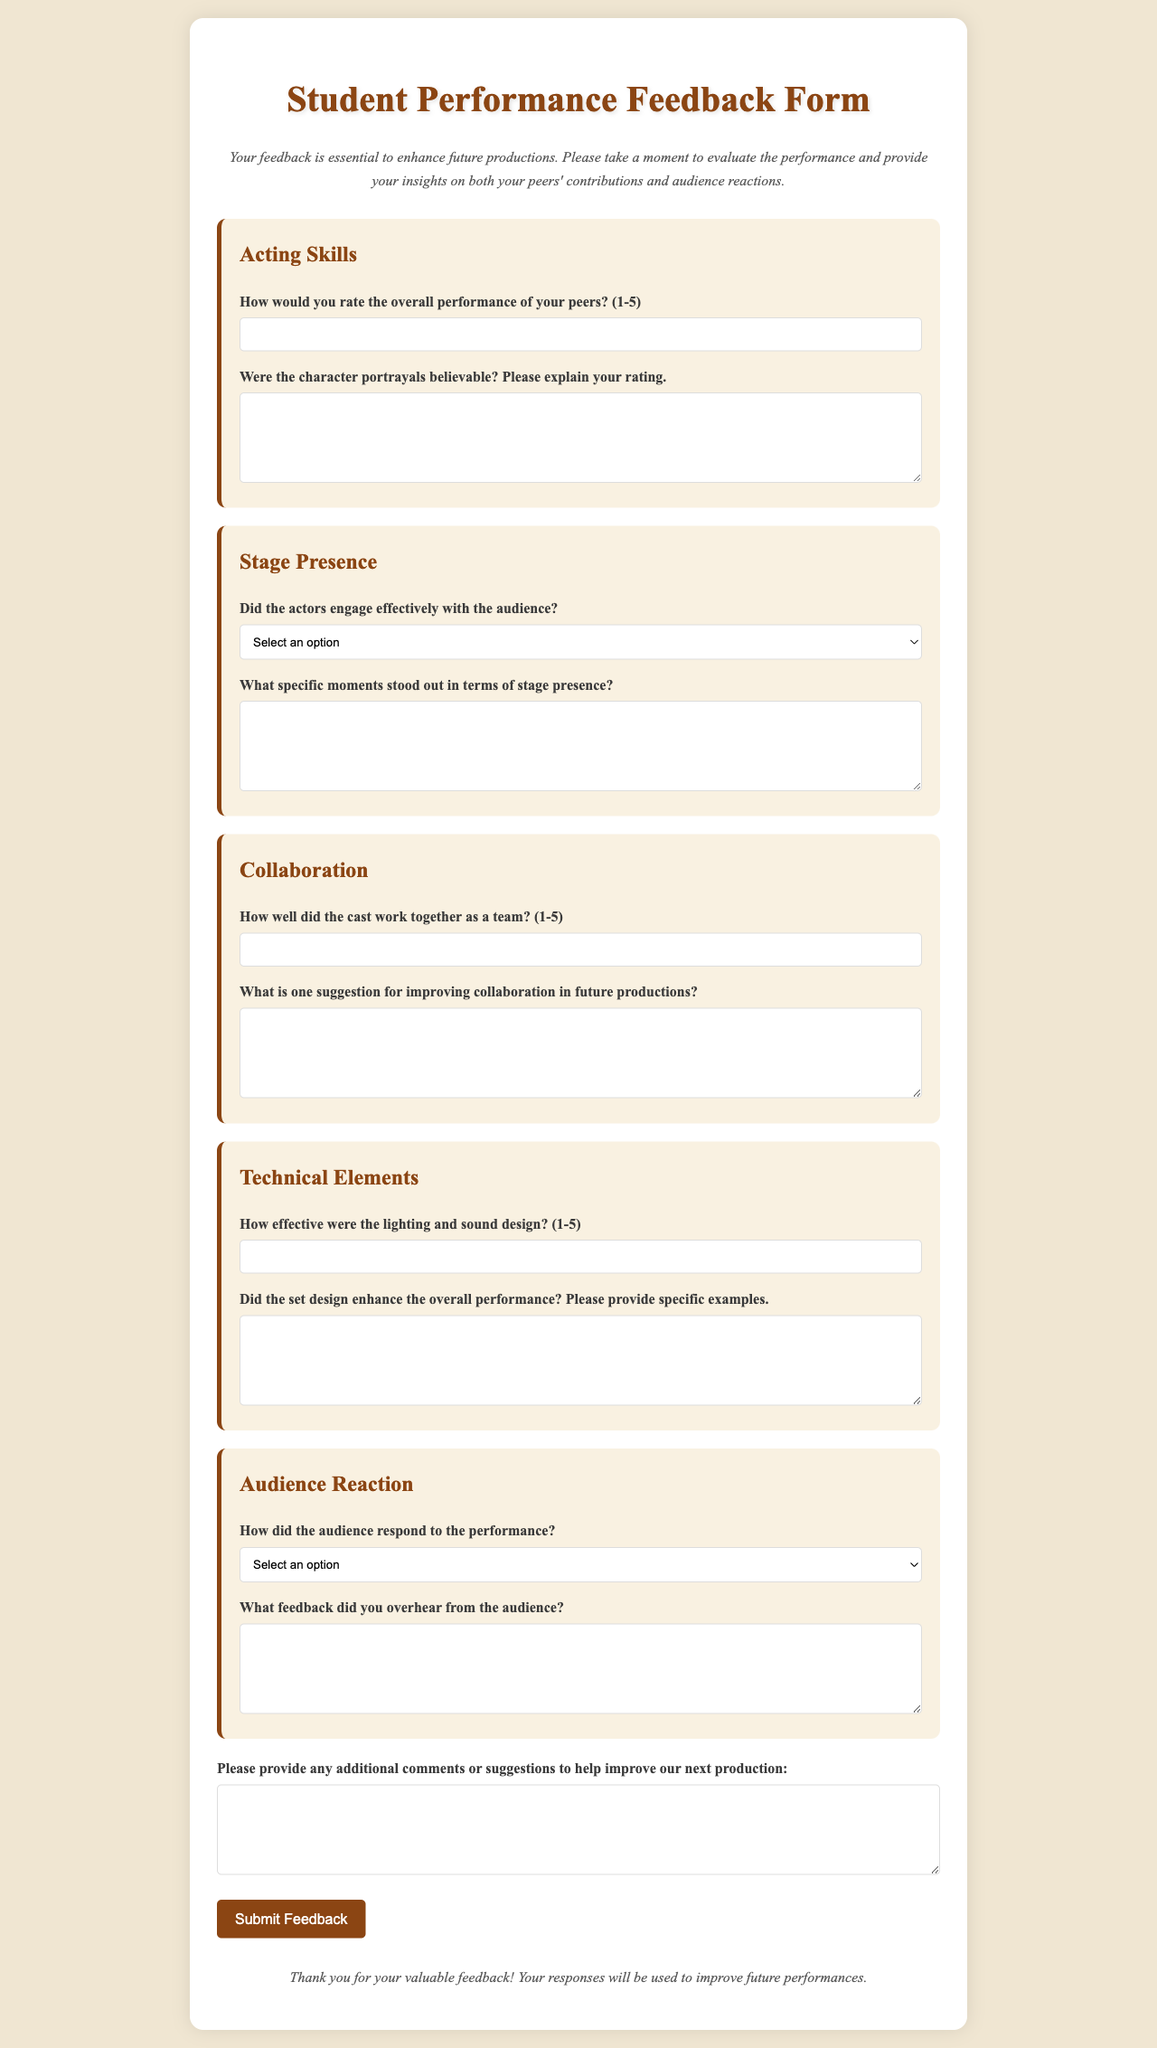What is the title of the document? The title of the document is specified in the <title> tag, which is "Student Performance Feedback Form."
Answer: Student Performance Feedback Form How many categories are in the feedback form? The number of categories is indicated by the number of <div class="category"> sections within the form. There are five categories.
Answer: 5 What is the maximum rating for acting skills? The maximum rating is given in the input field where users can rate the overall performance of peers on a scale of 1 to 5.
Answer: 5 What does the audience engagement question ask for? The audience engagement question is looking for a response about whether the actors engaged effectively with the audience, indicated in the label.
Answer: Yes or No What suggestion is requested for improving collaboration? The feedback form includes a specific question asking for one suggestion to improve collaboration in future productions, which is noted in the respective section.
Answer: Open-ended response How does the form indicate the desired format of feedback? The desired format of feedback is indicated by use of required attributes in the input fields and textareas, showing that responses must be filled out.
Answer: Required What color theme is dominant in the document? The document displays a consistent color theme that features shades of brown and beige, specifically #8b4513 and #f0e6d2 colors.
Answer: Brown and beige What type of feedback is solicited from peers regarding character portrayals? Peers are asked to evaluate the believability of character portrayals and to explain their ratings, indicating a qualitative aspect to the feedback.
Answer: Open-ended response 